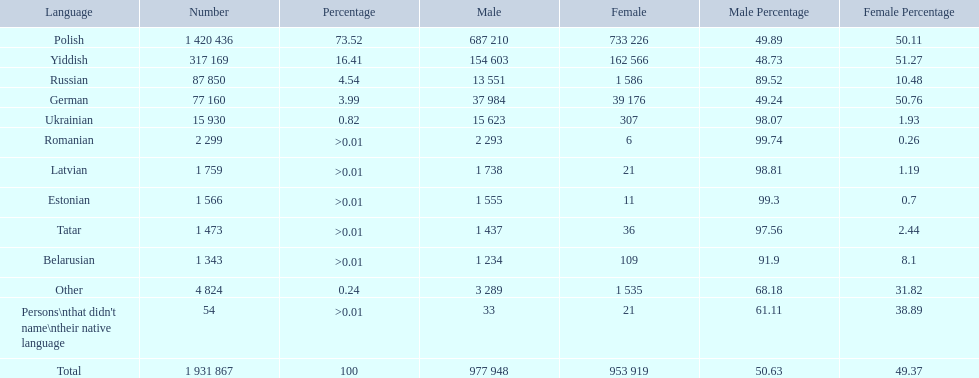What named native languages spoken in the warsaw governorate have more males then females? Russian, Ukrainian, Romanian, Latvian, Estonian, Tatar, Belarusian. Which of those have less then 500 males listed? Romanian, Latvian, Estonian, Tatar, Belarusian. Of the remaining languages which of them have less then 20 females? Romanian, Estonian. Which of these has the highest total number listed? Romanian. 